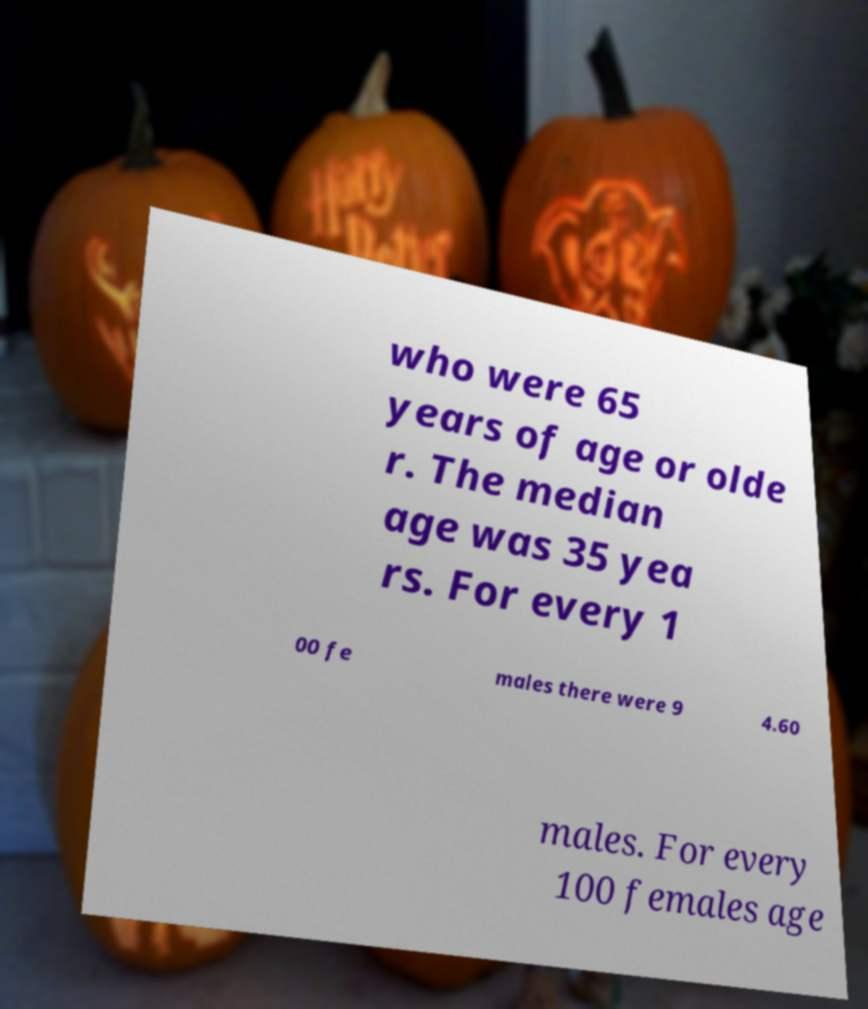Can you read and provide the text displayed in the image?This photo seems to have some interesting text. Can you extract and type it out for me? who were 65 years of age or olde r. The median age was 35 yea rs. For every 1 00 fe males there were 9 4.60 males. For every 100 females age 